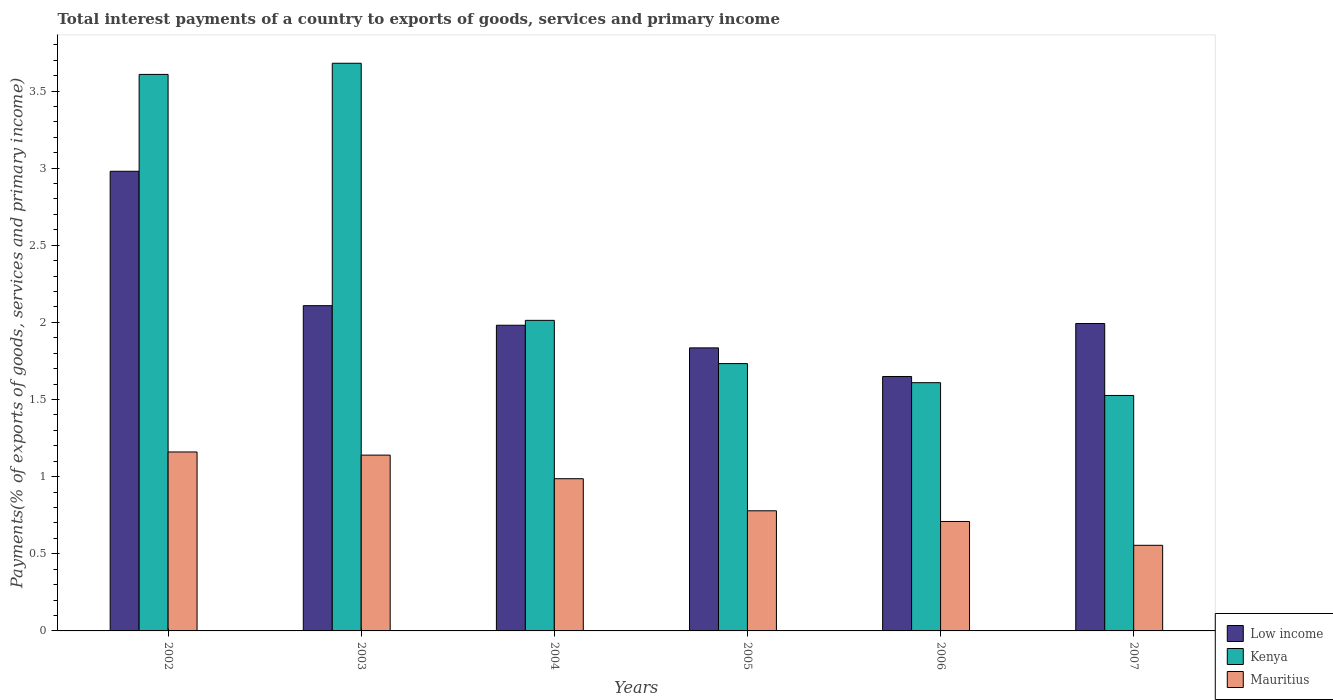Are the number of bars per tick equal to the number of legend labels?
Give a very brief answer. Yes. How many bars are there on the 3rd tick from the left?
Make the answer very short. 3. How many bars are there on the 1st tick from the right?
Provide a short and direct response. 3. What is the total interest payments in Kenya in 2006?
Provide a succinct answer. 1.61. Across all years, what is the maximum total interest payments in Kenya?
Offer a terse response. 3.68. Across all years, what is the minimum total interest payments in Low income?
Give a very brief answer. 1.65. What is the total total interest payments in Mauritius in the graph?
Make the answer very short. 5.33. What is the difference between the total interest payments in Low income in 2005 and that in 2006?
Make the answer very short. 0.19. What is the difference between the total interest payments in Low income in 2003 and the total interest payments in Kenya in 2004?
Provide a short and direct response. 0.1. What is the average total interest payments in Mauritius per year?
Provide a short and direct response. 0.89. In the year 2005, what is the difference between the total interest payments in Mauritius and total interest payments in Low income?
Provide a succinct answer. -1.06. In how many years, is the total interest payments in Kenya greater than 0.5 %?
Offer a very short reply. 6. What is the ratio of the total interest payments in Kenya in 2004 to that in 2007?
Give a very brief answer. 1.32. What is the difference between the highest and the second highest total interest payments in Kenya?
Your answer should be very brief. 0.07. What is the difference between the highest and the lowest total interest payments in Kenya?
Offer a very short reply. 2.15. Is the sum of the total interest payments in Low income in 2002 and 2003 greater than the maximum total interest payments in Kenya across all years?
Ensure brevity in your answer.  Yes. What does the 3rd bar from the left in 2002 represents?
Ensure brevity in your answer.  Mauritius. Is it the case that in every year, the sum of the total interest payments in Kenya and total interest payments in Low income is greater than the total interest payments in Mauritius?
Keep it short and to the point. Yes. How many bars are there?
Your answer should be compact. 18. How many years are there in the graph?
Provide a short and direct response. 6. What is the difference between two consecutive major ticks on the Y-axis?
Your answer should be compact. 0.5. Does the graph contain any zero values?
Offer a very short reply. No. Does the graph contain grids?
Offer a terse response. No. Where does the legend appear in the graph?
Offer a very short reply. Bottom right. What is the title of the graph?
Your answer should be very brief. Total interest payments of a country to exports of goods, services and primary income. What is the label or title of the Y-axis?
Provide a succinct answer. Payments(% of exports of goods, services and primary income). What is the Payments(% of exports of goods, services and primary income) in Low income in 2002?
Give a very brief answer. 2.98. What is the Payments(% of exports of goods, services and primary income) of Kenya in 2002?
Ensure brevity in your answer.  3.61. What is the Payments(% of exports of goods, services and primary income) in Mauritius in 2002?
Make the answer very short. 1.16. What is the Payments(% of exports of goods, services and primary income) in Low income in 2003?
Offer a terse response. 2.11. What is the Payments(% of exports of goods, services and primary income) in Kenya in 2003?
Provide a short and direct response. 3.68. What is the Payments(% of exports of goods, services and primary income) of Mauritius in 2003?
Your answer should be very brief. 1.14. What is the Payments(% of exports of goods, services and primary income) of Low income in 2004?
Make the answer very short. 1.98. What is the Payments(% of exports of goods, services and primary income) of Kenya in 2004?
Provide a succinct answer. 2.01. What is the Payments(% of exports of goods, services and primary income) in Mauritius in 2004?
Give a very brief answer. 0.99. What is the Payments(% of exports of goods, services and primary income) in Low income in 2005?
Ensure brevity in your answer.  1.83. What is the Payments(% of exports of goods, services and primary income) of Kenya in 2005?
Provide a succinct answer. 1.73. What is the Payments(% of exports of goods, services and primary income) in Mauritius in 2005?
Provide a succinct answer. 0.78. What is the Payments(% of exports of goods, services and primary income) of Low income in 2006?
Your answer should be very brief. 1.65. What is the Payments(% of exports of goods, services and primary income) of Kenya in 2006?
Make the answer very short. 1.61. What is the Payments(% of exports of goods, services and primary income) of Mauritius in 2006?
Ensure brevity in your answer.  0.71. What is the Payments(% of exports of goods, services and primary income) of Low income in 2007?
Provide a succinct answer. 1.99. What is the Payments(% of exports of goods, services and primary income) of Kenya in 2007?
Offer a terse response. 1.53. What is the Payments(% of exports of goods, services and primary income) in Mauritius in 2007?
Give a very brief answer. 0.56. Across all years, what is the maximum Payments(% of exports of goods, services and primary income) in Low income?
Ensure brevity in your answer.  2.98. Across all years, what is the maximum Payments(% of exports of goods, services and primary income) of Kenya?
Make the answer very short. 3.68. Across all years, what is the maximum Payments(% of exports of goods, services and primary income) of Mauritius?
Give a very brief answer. 1.16. Across all years, what is the minimum Payments(% of exports of goods, services and primary income) in Low income?
Your answer should be compact. 1.65. Across all years, what is the minimum Payments(% of exports of goods, services and primary income) in Kenya?
Your response must be concise. 1.53. Across all years, what is the minimum Payments(% of exports of goods, services and primary income) in Mauritius?
Provide a succinct answer. 0.56. What is the total Payments(% of exports of goods, services and primary income) in Low income in the graph?
Offer a terse response. 12.55. What is the total Payments(% of exports of goods, services and primary income) in Kenya in the graph?
Your answer should be compact. 14.17. What is the total Payments(% of exports of goods, services and primary income) in Mauritius in the graph?
Offer a terse response. 5.33. What is the difference between the Payments(% of exports of goods, services and primary income) in Low income in 2002 and that in 2003?
Your answer should be very brief. 0.87. What is the difference between the Payments(% of exports of goods, services and primary income) in Kenya in 2002 and that in 2003?
Keep it short and to the point. -0.07. What is the difference between the Payments(% of exports of goods, services and primary income) of Mauritius in 2002 and that in 2003?
Keep it short and to the point. 0.02. What is the difference between the Payments(% of exports of goods, services and primary income) in Kenya in 2002 and that in 2004?
Provide a succinct answer. 1.59. What is the difference between the Payments(% of exports of goods, services and primary income) of Mauritius in 2002 and that in 2004?
Keep it short and to the point. 0.17. What is the difference between the Payments(% of exports of goods, services and primary income) in Low income in 2002 and that in 2005?
Provide a succinct answer. 1.14. What is the difference between the Payments(% of exports of goods, services and primary income) of Kenya in 2002 and that in 2005?
Make the answer very short. 1.87. What is the difference between the Payments(% of exports of goods, services and primary income) of Mauritius in 2002 and that in 2005?
Your answer should be very brief. 0.38. What is the difference between the Payments(% of exports of goods, services and primary income) in Low income in 2002 and that in 2006?
Provide a succinct answer. 1.33. What is the difference between the Payments(% of exports of goods, services and primary income) in Kenya in 2002 and that in 2006?
Keep it short and to the point. 2. What is the difference between the Payments(% of exports of goods, services and primary income) of Mauritius in 2002 and that in 2006?
Your answer should be very brief. 0.45. What is the difference between the Payments(% of exports of goods, services and primary income) of Low income in 2002 and that in 2007?
Your answer should be compact. 0.99. What is the difference between the Payments(% of exports of goods, services and primary income) in Kenya in 2002 and that in 2007?
Keep it short and to the point. 2.08. What is the difference between the Payments(% of exports of goods, services and primary income) of Mauritius in 2002 and that in 2007?
Your response must be concise. 0.61. What is the difference between the Payments(% of exports of goods, services and primary income) in Low income in 2003 and that in 2004?
Offer a very short reply. 0.13. What is the difference between the Payments(% of exports of goods, services and primary income) in Kenya in 2003 and that in 2004?
Provide a short and direct response. 1.67. What is the difference between the Payments(% of exports of goods, services and primary income) of Mauritius in 2003 and that in 2004?
Offer a very short reply. 0.15. What is the difference between the Payments(% of exports of goods, services and primary income) of Low income in 2003 and that in 2005?
Offer a terse response. 0.27. What is the difference between the Payments(% of exports of goods, services and primary income) of Kenya in 2003 and that in 2005?
Provide a short and direct response. 1.95. What is the difference between the Payments(% of exports of goods, services and primary income) of Mauritius in 2003 and that in 2005?
Offer a very short reply. 0.36. What is the difference between the Payments(% of exports of goods, services and primary income) in Low income in 2003 and that in 2006?
Give a very brief answer. 0.46. What is the difference between the Payments(% of exports of goods, services and primary income) of Kenya in 2003 and that in 2006?
Offer a terse response. 2.07. What is the difference between the Payments(% of exports of goods, services and primary income) of Mauritius in 2003 and that in 2006?
Your answer should be compact. 0.43. What is the difference between the Payments(% of exports of goods, services and primary income) in Low income in 2003 and that in 2007?
Your answer should be very brief. 0.12. What is the difference between the Payments(% of exports of goods, services and primary income) in Kenya in 2003 and that in 2007?
Keep it short and to the point. 2.15. What is the difference between the Payments(% of exports of goods, services and primary income) of Mauritius in 2003 and that in 2007?
Provide a short and direct response. 0.58. What is the difference between the Payments(% of exports of goods, services and primary income) of Low income in 2004 and that in 2005?
Your answer should be compact. 0.15. What is the difference between the Payments(% of exports of goods, services and primary income) in Kenya in 2004 and that in 2005?
Give a very brief answer. 0.28. What is the difference between the Payments(% of exports of goods, services and primary income) in Mauritius in 2004 and that in 2005?
Offer a very short reply. 0.21. What is the difference between the Payments(% of exports of goods, services and primary income) in Low income in 2004 and that in 2006?
Your answer should be compact. 0.33. What is the difference between the Payments(% of exports of goods, services and primary income) of Kenya in 2004 and that in 2006?
Provide a short and direct response. 0.4. What is the difference between the Payments(% of exports of goods, services and primary income) in Mauritius in 2004 and that in 2006?
Offer a terse response. 0.28. What is the difference between the Payments(% of exports of goods, services and primary income) of Low income in 2004 and that in 2007?
Offer a terse response. -0.01. What is the difference between the Payments(% of exports of goods, services and primary income) in Kenya in 2004 and that in 2007?
Your answer should be compact. 0.49. What is the difference between the Payments(% of exports of goods, services and primary income) in Mauritius in 2004 and that in 2007?
Provide a succinct answer. 0.43. What is the difference between the Payments(% of exports of goods, services and primary income) in Low income in 2005 and that in 2006?
Give a very brief answer. 0.19. What is the difference between the Payments(% of exports of goods, services and primary income) of Kenya in 2005 and that in 2006?
Your answer should be compact. 0.12. What is the difference between the Payments(% of exports of goods, services and primary income) in Mauritius in 2005 and that in 2006?
Provide a short and direct response. 0.07. What is the difference between the Payments(% of exports of goods, services and primary income) of Low income in 2005 and that in 2007?
Give a very brief answer. -0.16. What is the difference between the Payments(% of exports of goods, services and primary income) in Kenya in 2005 and that in 2007?
Offer a terse response. 0.21. What is the difference between the Payments(% of exports of goods, services and primary income) in Mauritius in 2005 and that in 2007?
Offer a very short reply. 0.22. What is the difference between the Payments(% of exports of goods, services and primary income) of Low income in 2006 and that in 2007?
Make the answer very short. -0.34. What is the difference between the Payments(% of exports of goods, services and primary income) in Kenya in 2006 and that in 2007?
Ensure brevity in your answer.  0.08. What is the difference between the Payments(% of exports of goods, services and primary income) in Mauritius in 2006 and that in 2007?
Keep it short and to the point. 0.15. What is the difference between the Payments(% of exports of goods, services and primary income) in Low income in 2002 and the Payments(% of exports of goods, services and primary income) in Kenya in 2003?
Your answer should be compact. -0.7. What is the difference between the Payments(% of exports of goods, services and primary income) of Low income in 2002 and the Payments(% of exports of goods, services and primary income) of Mauritius in 2003?
Provide a succinct answer. 1.84. What is the difference between the Payments(% of exports of goods, services and primary income) of Kenya in 2002 and the Payments(% of exports of goods, services and primary income) of Mauritius in 2003?
Provide a succinct answer. 2.47. What is the difference between the Payments(% of exports of goods, services and primary income) of Low income in 2002 and the Payments(% of exports of goods, services and primary income) of Kenya in 2004?
Your answer should be very brief. 0.97. What is the difference between the Payments(% of exports of goods, services and primary income) in Low income in 2002 and the Payments(% of exports of goods, services and primary income) in Mauritius in 2004?
Ensure brevity in your answer.  1.99. What is the difference between the Payments(% of exports of goods, services and primary income) in Kenya in 2002 and the Payments(% of exports of goods, services and primary income) in Mauritius in 2004?
Make the answer very short. 2.62. What is the difference between the Payments(% of exports of goods, services and primary income) of Low income in 2002 and the Payments(% of exports of goods, services and primary income) of Kenya in 2005?
Ensure brevity in your answer.  1.25. What is the difference between the Payments(% of exports of goods, services and primary income) in Low income in 2002 and the Payments(% of exports of goods, services and primary income) in Mauritius in 2005?
Your answer should be compact. 2.2. What is the difference between the Payments(% of exports of goods, services and primary income) in Kenya in 2002 and the Payments(% of exports of goods, services and primary income) in Mauritius in 2005?
Offer a very short reply. 2.83. What is the difference between the Payments(% of exports of goods, services and primary income) in Low income in 2002 and the Payments(% of exports of goods, services and primary income) in Kenya in 2006?
Offer a terse response. 1.37. What is the difference between the Payments(% of exports of goods, services and primary income) of Low income in 2002 and the Payments(% of exports of goods, services and primary income) of Mauritius in 2006?
Provide a succinct answer. 2.27. What is the difference between the Payments(% of exports of goods, services and primary income) of Kenya in 2002 and the Payments(% of exports of goods, services and primary income) of Mauritius in 2006?
Make the answer very short. 2.9. What is the difference between the Payments(% of exports of goods, services and primary income) in Low income in 2002 and the Payments(% of exports of goods, services and primary income) in Kenya in 2007?
Offer a terse response. 1.45. What is the difference between the Payments(% of exports of goods, services and primary income) in Low income in 2002 and the Payments(% of exports of goods, services and primary income) in Mauritius in 2007?
Keep it short and to the point. 2.42. What is the difference between the Payments(% of exports of goods, services and primary income) of Kenya in 2002 and the Payments(% of exports of goods, services and primary income) of Mauritius in 2007?
Keep it short and to the point. 3.05. What is the difference between the Payments(% of exports of goods, services and primary income) in Low income in 2003 and the Payments(% of exports of goods, services and primary income) in Kenya in 2004?
Offer a very short reply. 0.1. What is the difference between the Payments(% of exports of goods, services and primary income) of Low income in 2003 and the Payments(% of exports of goods, services and primary income) of Mauritius in 2004?
Your response must be concise. 1.12. What is the difference between the Payments(% of exports of goods, services and primary income) in Kenya in 2003 and the Payments(% of exports of goods, services and primary income) in Mauritius in 2004?
Your answer should be very brief. 2.69. What is the difference between the Payments(% of exports of goods, services and primary income) of Low income in 2003 and the Payments(% of exports of goods, services and primary income) of Kenya in 2005?
Your answer should be very brief. 0.38. What is the difference between the Payments(% of exports of goods, services and primary income) in Low income in 2003 and the Payments(% of exports of goods, services and primary income) in Mauritius in 2005?
Your response must be concise. 1.33. What is the difference between the Payments(% of exports of goods, services and primary income) of Kenya in 2003 and the Payments(% of exports of goods, services and primary income) of Mauritius in 2005?
Your response must be concise. 2.9. What is the difference between the Payments(% of exports of goods, services and primary income) of Low income in 2003 and the Payments(% of exports of goods, services and primary income) of Kenya in 2006?
Keep it short and to the point. 0.5. What is the difference between the Payments(% of exports of goods, services and primary income) of Low income in 2003 and the Payments(% of exports of goods, services and primary income) of Mauritius in 2006?
Offer a very short reply. 1.4. What is the difference between the Payments(% of exports of goods, services and primary income) in Kenya in 2003 and the Payments(% of exports of goods, services and primary income) in Mauritius in 2006?
Make the answer very short. 2.97. What is the difference between the Payments(% of exports of goods, services and primary income) of Low income in 2003 and the Payments(% of exports of goods, services and primary income) of Kenya in 2007?
Provide a succinct answer. 0.58. What is the difference between the Payments(% of exports of goods, services and primary income) of Low income in 2003 and the Payments(% of exports of goods, services and primary income) of Mauritius in 2007?
Provide a succinct answer. 1.55. What is the difference between the Payments(% of exports of goods, services and primary income) of Kenya in 2003 and the Payments(% of exports of goods, services and primary income) of Mauritius in 2007?
Keep it short and to the point. 3.12. What is the difference between the Payments(% of exports of goods, services and primary income) of Low income in 2004 and the Payments(% of exports of goods, services and primary income) of Kenya in 2005?
Provide a short and direct response. 0.25. What is the difference between the Payments(% of exports of goods, services and primary income) of Low income in 2004 and the Payments(% of exports of goods, services and primary income) of Mauritius in 2005?
Keep it short and to the point. 1.2. What is the difference between the Payments(% of exports of goods, services and primary income) of Kenya in 2004 and the Payments(% of exports of goods, services and primary income) of Mauritius in 2005?
Give a very brief answer. 1.23. What is the difference between the Payments(% of exports of goods, services and primary income) of Low income in 2004 and the Payments(% of exports of goods, services and primary income) of Kenya in 2006?
Make the answer very short. 0.37. What is the difference between the Payments(% of exports of goods, services and primary income) of Low income in 2004 and the Payments(% of exports of goods, services and primary income) of Mauritius in 2006?
Provide a succinct answer. 1.27. What is the difference between the Payments(% of exports of goods, services and primary income) in Kenya in 2004 and the Payments(% of exports of goods, services and primary income) in Mauritius in 2006?
Ensure brevity in your answer.  1.3. What is the difference between the Payments(% of exports of goods, services and primary income) of Low income in 2004 and the Payments(% of exports of goods, services and primary income) of Kenya in 2007?
Make the answer very short. 0.46. What is the difference between the Payments(% of exports of goods, services and primary income) in Low income in 2004 and the Payments(% of exports of goods, services and primary income) in Mauritius in 2007?
Provide a succinct answer. 1.43. What is the difference between the Payments(% of exports of goods, services and primary income) in Kenya in 2004 and the Payments(% of exports of goods, services and primary income) in Mauritius in 2007?
Make the answer very short. 1.46. What is the difference between the Payments(% of exports of goods, services and primary income) in Low income in 2005 and the Payments(% of exports of goods, services and primary income) in Kenya in 2006?
Make the answer very short. 0.23. What is the difference between the Payments(% of exports of goods, services and primary income) in Low income in 2005 and the Payments(% of exports of goods, services and primary income) in Mauritius in 2006?
Offer a very short reply. 1.13. What is the difference between the Payments(% of exports of goods, services and primary income) in Kenya in 2005 and the Payments(% of exports of goods, services and primary income) in Mauritius in 2006?
Ensure brevity in your answer.  1.02. What is the difference between the Payments(% of exports of goods, services and primary income) in Low income in 2005 and the Payments(% of exports of goods, services and primary income) in Kenya in 2007?
Make the answer very short. 0.31. What is the difference between the Payments(% of exports of goods, services and primary income) of Low income in 2005 and the Payments(% of exports of goods, services and primary income) of Mauritius in 2007?
Provide a succinct answer. 1.28. What is the difference between the Payments(% of exports of goods, services and primary income) in Kenya in 2005 and the Payments(% of exports of goods, services and primary income) in Mauritius in 2007?
Provide a succinct answer. 1.18. What is the difference between the Payments(% of exports of goods, services and primary income) of Low income in 2006 and the Payments(% of exports of goods, services and primary income) of Kenya in 2007?
Offer a very short reply. 0.12. What is the difference between the Payments(% of exports of goods, services and primary income) of Low income in 2006 and the Payments(% of exports of goods, services and primary income) of Mauritius in 2007?
Provide a succinct answer. 1.09. What is the difference between the Payments(% of exports of goods, services and primary income) in Kenya in 2006 and the Payments(% of exports of goods, services and primary income) in Mauritius in 2007?
Provide a succinct answer. 1.05. What is the average Payments(% of exports of goods, services and primary income) in Low income per year?
Your answer should be compact. 2.09. What is the average Payments(% of exports of goods, services and primary income) in Kenya per year?
Your answer should be very brief. 2.36. What is the average Payments(% of exports of goods, services and primary income) of Mauritius per year?
Your answer should be very brief. 0.89. In the year 2002, what is the difference between the Payments(% of exports of goods, services and primary income) in Low income and Payments(% of exports of goods, services and primary income) in Kenya?
Offer a terse response. -0.63. In the year 2002, what is the difference between the Payments(% of exports of goods, services and primary income) of Low income and Payments(% of exports of goods, services and primary income) of Mauritius?
Make the answer very short. 1.82. In the year 2002, what is the difference between the Payments(% of exports of goods, services and primary income) in Kenya and Payments(% of exports of goods, services and primary income) in Mauritius?
Your answer should be very brief. 2.45. In the year 2003, what is the difference between the Payments(% of exports of goods, services and primary income) of Low income and Payments(% of exports of goods, services and primary income) of Kenya?
Give a very brief answer. -1.57. In the year 2003, what is the difference between the Payments(% of exports of goods, services and primary income) of Low income and Payments(% of exports of goods, services and primary income) of Mauritius?
Offer a very short reply. 0.97. In the year 2003, what is the difference between the Payments(% of exports of goods, services and primary income) of Kenya and Payments(% of exports of goods, services and primary income) of Mauritius?
Ensure brevity in your answer.  2.54. In the year 2004, what is the difference between the Payments(% of exports of goods, services and primary income) in Low income and Payments(% of exports of goods, services and primary income) in Kenya?
Give a very brief answer. -0.03. In the year 2004, what is the difference between the Payments(% of exports of goods, services and primary income) in Low income and Payments(% of exports of goods, services and primary income) in Mauritius?
Your response must be concise. 0.99. In the year 2004, what is the difference between the Payments(% of exports of goods, services and primary income) in Kenya and Payments(% of exports of goods, services and primary income) in Mauritius?
Offer a terse response. 1.03. In the year 2005, what is the difference between the Payments(% of exports of goods, services and primary income) of Low income and Payments(% of exports of goods, services and primary income) of Kenya?
Keep it short and to the point. 0.1. In the year 2005, what is the difference between the Payments(% of exports of goods, services and primary income) in Low income and Payments(% of exports of goods, services and primary income) in Mauritius?
Provide a succinct answer. 1.06. In the year 2005, what is the difference between the Payments(% of exports of goods, services and primary income) in Kenya and Payments(% of exports of goods, services and primary income) in Mauritius?
Keep it short and to the point. 0.95. In the year 2006, what is the difference between the Payments(% of exports of goods, services and primary income) of Low income and Payments(% of exports of goods, services and primary income) of Kenya?
Your response must be concise. 0.04. In the year 2006, what is the difference between the Payments(% of exports of goods, services and primary income) in Low income and Payments(% of exports of goods, services and primary income) in Mauritius?
Make the answer very short. 0.94. In the year 2006, what is the difference between the Payments(% of exports of goods, services and primary income) in Kenya and Payments(% of exports of goods, services and primary income) in Mauritius?
Your answer should be very brief. 0.9. In the year 2007, what is the difference between the Payments(% of exports of goods, services and primary income) in Low income and Payments(% of exports of goods, services and primary income) in Kenya?
Give a very brief answer. 0.47. In the year 2007, what is the difference between the Payments(% of exports of goods, services and primary income) in Low income and Payments(% of exports of goods, services and primary income) in Mauritius?
Offer a very short reply. 1.44. In the year 2007, what is the difference between the Payments(% of exports of goods, services and primary income) in Kenya and Payments(% of exports of goods, services and primary income) in Mauritius?
Ensure brevity in your answer.  0.97. What is the ratio of the Payments(% of exports of goods, services and primary income) in Low income in 2002 to that in 2003?
Make the answer very short. 1.41. What is the ratio of the Payments(% of exports of goods, services and primary income) in Kenya in 2002 to that in 2003?
Provide a short and direct response. 0.98. What is the ratio of the Payments(% of exports of goods, services and primary income) in Mauritius in 2002 to that in 2003?
Provide a succinct answer. 1.02. What is the ratio of the Payments(% of exports of goods, services and primary income) of Low income in 2002 to that in 2004?
Offer a terse response. 1.5. What is the ratio of the Payments(% of exports of goods, services and primary income) in Kenya in 2002 to that in 2004?
Give a very brief answer. 1.79. What is the ratio of the Payments(% of exports of goods, services and primary income) in Mauritius in 2002 to that in 2004?
Give a very brief answer. 1.18. What is the ratio of the Payments(% of exports of goods, services and primary income) in Low income in 2002 to that in 2005?
Provide a short and direct response. 1.62. What is the ratio of the Payments(% of exports of goods, services and primary income) in Kenya in 2002 to that in 2005?
Your answer should be very brief. 2.08. What is the ratio of the Payments(% of exports of goods, services and primary income) of Mauritius in 2002 to that in 2005?
Make the answer very short. 1.49. What is the ratio of the Payments(% of exports of goods, services and primary income) of Low income in 2002 to that in 2006?
Provide a succinct answer. 1.81. What is the ratio of the Payments(% of exports of goods, services and primary income) of Kenya in 2002 to that in 2006?
Keep it short and to the point. 2.24. What is the ratio of the Payments(% of exports of goods, services and primary income) in Mauritius in 2002 to that in 2006?
Make the answer very short. 1.64. What is the ratio of the Payments(% of exports of goods, services and primary income) in Low income in 2002 to that in 2007?
Provide a short and direct response. 1.5. What is the ratio of the Payments(% of exports of goods, services and primary income) of Kenya in 2002 to that in 2007?
Your answer should be very brief. 2.36. What is the ratio of the Payments(% of exports of goods, services and primary income) of Mauritius in 2002 to that in 2007?
Keep it short and to the point. 2.09. What is the ratio of the Payments(% of exports of goods, services and primary income) in Low income in 2003 to that in 2004?
Your answer should be very brief. 1.06. What is the ratio of the Payments(% of exports of goods, services and primary income) of Kenya in 2003 to that in 2004?
Give a very brief answer. 1.83. What is the ratio of the Payments(% of exports of goods, services and primary income) in Mauritius in 2003 to that in 2004?
Make the answer very short. 1.16. What is the ratio of the Payments(% of exports of goods, services and primary income) in Low income in 2003 to that in 2005?
Offer a very short reply. 1.15. What is the ratio of the Payments(% of exports of goods, services and primary income) of Kenya in 2003 to that in 2005?
Provide a succinct answer. 2.12. What is the ratio of the Payments(% of exports of goods, services and primary income) in Mauritius in 2003 to that in 2005?
Offer a terse response. 1.46. What is the ratio of the Payments(% of exports of goods, services and primary income) of Low income in 2003 to that in 2006?
Offer a very short reply. 1.28. What is the ratio of the Payments(% of exports of goods, services and primary income) in Kenya in 2003 to that in 2006?
Keep it short and to the point. 2.29. What is the ratio of the Payments(% of exports of goods, services and primary income) of Mauritius in 2003 to that in 2006?
Keep it short and to the point. 1.61. What is the ratio of the Payments(% of exports of goods, services and primary income) of Low income in 2003 to that in 2007?
Your answer should be compact. 1.06. What is the ratio of the Payments(% of exports of goods, services and primary income) of Kenya in 2003 to that in 2007?
Keep it short and to the point. 2.41. What is the ratio of the Payments(% of exports of goods, services and primary income) in Mauritius in 2003 to that in 2007?
Give a very brief answer. 2.05. What is the ratio of the Payments(% of exports of goods, services and primary income) in Low income in 2004 to that in 2005?
Keep it short and to the point. 1.08. What is the ratio of the Payments(% of exports of goods, services and primary income) of Kenya in 2004 to that in 2005?
Your response must be concise. 1.16. What is the ratio of the Payments(% of exports of goods, services and primary income) in Mauritius in 2004 to that in 2005?
Give a very brief answer. 1.27. What is the ratio of the Payments(% of exports of goods, services and primary income) in Low income in 2004 to that in 2006?
Provide a succinct answer. 1.2. What is the ratio of the Payments(% of exports of goods, services and primary income) of Kenya in 2004 to that in 2006?
Provide a short and direct response. 1.25. What is the ratio of the Payments(% of exports of goods, services and primary income) in Mauritius in 2004 to that in 2006?
Provide a short and direct response. 1.39. What is the ratio of the Payments(% of exports of goods, services and primary income) of Low income in 2004 to that in 2007?
Provide a succinct answer. 0.99. What is the ratio of the Payments(% of exports of goods, services and primary income) in Kenya in 2004 to that in 2007?
Keep it short and to the point. 1.32. What is the ratio of the Payments(% of exports of goods, services and primary income) of Mauritius in 2004 to that in 2007?
Your answer should be very brief. 1.78. What is the ratio of the Payments(% of exports of goods, services and primary income) of Low income in 2005 to that in 2006?
Ensure brevity in your answer.  1.11. What is the ratio of the Payments(% of exports of goods, services and primary income) in Mauritius in 2005 to that in 2006?
Your answer should be compact. 1.1. What is the ratio of the Payments(% of exports of goods, services and primary income) of Low income in 2005 to that in 2007?
Offer a terse response. 0.92. What is the ratio of the Payments(% of exports of goods, services and primary income) in Kenya in 2005 to that in 2007?
Provide a short and direct response. 1.14. What is the ratio of the Payments(% of exports of goods, services and primary income) of Mauritius in 2005 to that in 2007?
Your answer should be compact. 1.4. What is the ratio of the Payments(% of exports of goods, services and primary income) in Low income in 2006 to that in 2007?
Provide a short and direct response. 0.83. What is the ratio of the Payments(% of exports of goods, services and primary income) of Kenya in 2006 to that in 2007?
Your answer should be very brief. 1.05. What is the ratio of the Payments(% of exports of goods, services and primary income) of Mauritius in 2006 to that in 2007?
Keep it short and to the point. 1.28. What is the difference between the highest and the second highest Payments(% of exports of goods, services and primary income) in Low income?
Offer a terse response. 0.87. What is the difference between the highest and the second highest Payments(% of exports of goods, services and primary income) in Kenya?
Offer a very short reply. 0.07. What is the difference between the highest and the second highest Payments(% of exports of goods, services and primary income) of Mauritius?
Keep it short and to the point. 0.02. What is the difference between the highest and the lowest Payments(% of exports of goods, services and primary income) in Low income?
Offer a terse response. 1.33. What is the difference between the highest and the lowest Payments(% of exports of goods, services and primary income) in Kenya?
Your answer should be compact. 2.15. What is the difference between the highest and the lowest Payments(% of exports of goods, services and primary income) in Mauritius?
Your response must be concise. 0.61. 